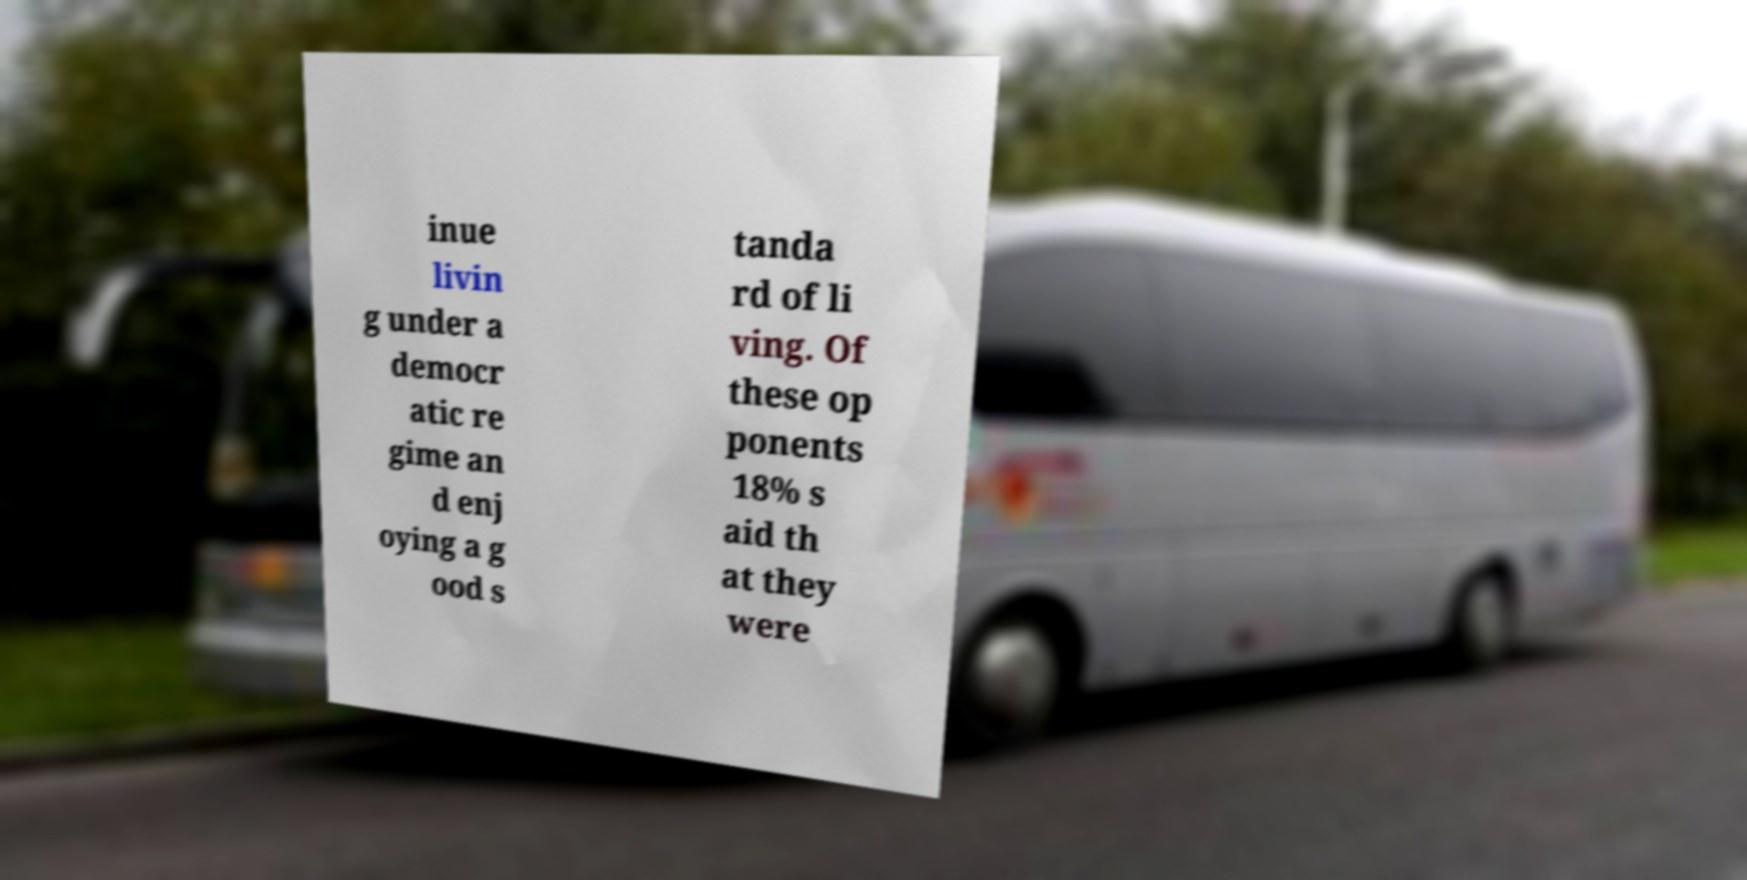Could you assist in decoding the text presented in this image and type it out clearly? inue livin g under a democr atic re gime an d enj oying a g ood s tanda rd of li ving. Of these op ponents 18% s aid th at they were 